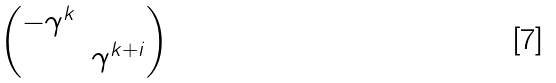Convert formula to latex. <formula><loc_0><loc_0><loc_500><loc_500>\begin{pmatrix} - \gamma ^ { k } & \\ & \gamma ^ { k + i } \\ \end{pmatrix}</formula> 